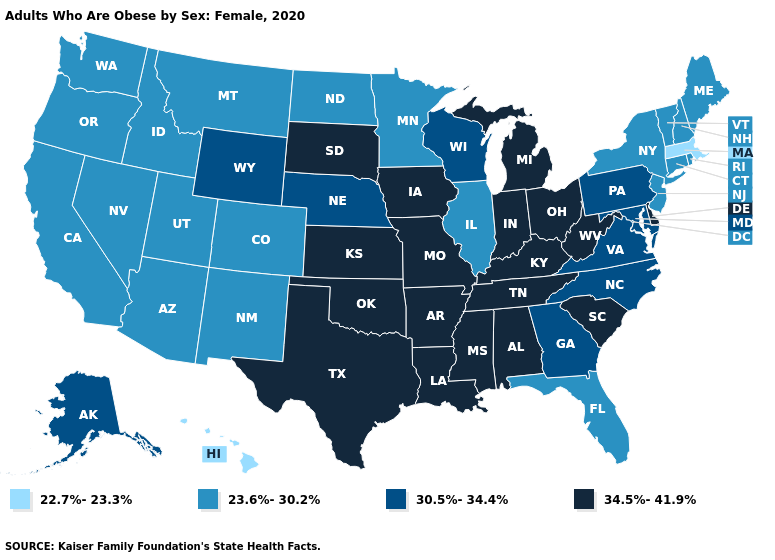Which states have the highest value in the USA?
Write a very short answer. Alabama, Arkansas, Delaware, Indiana, Iowa, Kansas, Kentucky, Louisiana, Michigan, Mississippi, Missouri, Ohio, Oklahoma, South Carolina, South Dakota, Tennessee, Texas, West Virginia. Does Maine have a lower value than Oklahoma?
Answer briefly. Yes. What is the value of Alaska?
Quick response, please. 30.5%-34.4%. What is the value of Alabama?
Keep it brief. 34.5%-41.9%. What is the value of West Virginia?
Concise answer only. 34.5%-41.9%. What is the lowest value in states that border California?
Short answer required. 23.6%-30.2%. What is the value of Maryland?
Answer briefly. 30.5%-34.4%. Among the states that border Arizona , which have the lowest value?
Keep it brief. California, Colorado, Nevada, New Mexico, Utah. What is the lowest value in the USA?
Write a very short answer. 22.7%-23.3%. What is the lowest value in the Northeast?
Quick response, please. 22.7%-23.3%. What is the value of California?
Give a very brief answer. 23.6%-30.2%. Does Oklahoma have a higher value than Alaska?
Give a very brief answer. Yes. Name the states that have a value in the range 22.7%-23.3%?
Quick response, please. Hawaii, Massachusetts. Name the states that have a value in the range 34.5%-41.9%?
Give a very brief answer. Alabama, Arkansas, Delaware, Indiana, Iowa, Kansas, Kentucky, Louisiana, Michigan, Mississippi, Missouri, Ohio, Oklahoma, South Carolina, South Dakota, Tennessee, Texas, West Virginia. Which states have the highest value in the USA?
Short answer required. Alabama, Arkansas, Delaware, Indiana, Iowa, Kansas, Kentucky, Louisiana, Michigan, Mississippi, Missouri, Ohio, Oklahoma, South Carolina, South Dakota, Tennessee, Texas, West Virginia. 